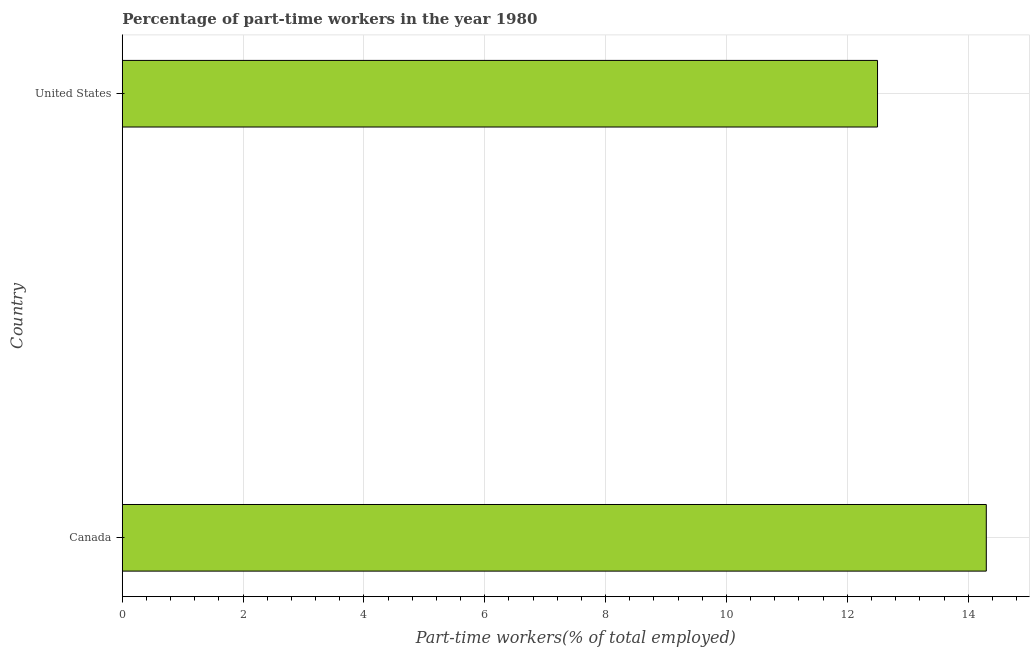What is the title of the graph?
Ensure brevity in your answer.  Percentage of part-time workers in the year 1980. What is the label or title of the X-axis?
Your answer should be very brief. Part-time workers(% of total employed). What is the label or title of the Y-axis?
Your answer should be compact. Country. What is the percentage of part-time workers in United States?
Give a very brief answer. 12.5. Across all countries, what is the maximum percentage of part-time workers?
Keep it short and to the point. 14.3. Across all countries, what is the minimum percentage of part-time workers?
Offer a very short reply. 12.5. What is the sum of the percentage of part-time workers?
Give a very brief answer. 26.8. What is the difference between the percentage of part-time workers in Canada and United States?
Provide a short and direct response. 1.8. What is the median percentage of part-time workers?
Ensure brevity in your answer.  13.4. In how many countries, is the percentage of part-time workers greater than 6.4 %?
Offer a very short reply. 2. What is the ratio of the percentage of part-time workers in Canada to that in United States?
Provide a short and direct response. 1.14. How many bars are there?
Make the answer very short. 2. What is the difference between two consecutive major ticks on the X-axis?
Provide a short and direct response. 2. What is the Part-time workers(% of total employed) of Canada?
Give a very brief answer. 14.3. What is the ratio of the Part-time workers(% of total employed) in Canada to that in United States?
Offer a terse response. 1.14. 